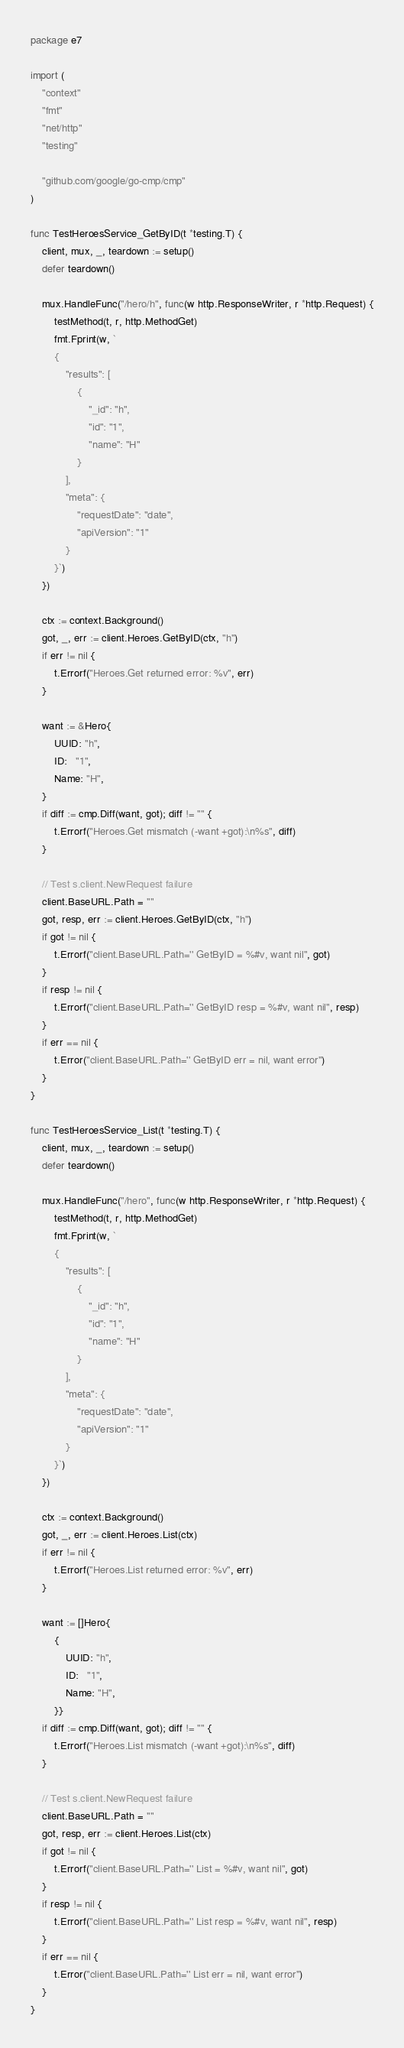Convert code to text. <code><loc_0><loc_0><loc_500><loc_500><_Go_>package e7

import (
	"context"
	"fmt"
	"net/http"
	"testing"

	"github.com/google/go-cmp/cmp"
)

func TestHeroesService_GetByID(t *testing.T) {
	client, mux, _, teardown := setup()
	defer teardown()

	mux.HandleFunc("/hero/h", func(w http.ResponseWriter, r *http.Request) {
		testMethod(t, r, http.MethodGet)
		fmt.Fprint(w, `
		{
			"results": [
				{
					"_id": "h",
					"id": "1",
					"name": "H"
				}
			],
			"meta": {
				"requestDate": "date",
				"apiVersion": "1"
			}
		}`)
	})

	ctx := context.Background()
	got, _, err := client.Heroes.GetByID(ctx, "h")
	if err != nil {
		t.Errorf("Heroes.Get returned error: %v", err)
	}

	want := &Hero{
		UUID: "h",
		ID:   "1",
		Name: "H",
	}
	if diff := cmp.Diff(want, got); diff != "" {
		t.Errorf("Heroes.Get mismatch (-want +got):\n%s", diff)
	}

	// Test s.client.NewRequest failure
	client.BaseURL.Path = ""
	got, resp, err := client.Heroes.GetByID(ctx, "h")
	if got != nil {
		t.Errorf("client.BaseURL.Path='' GetByID = %#v, want nil", got)
	}
	if resp != nil {
		t.Errorf("client.BaseURL.Path='' GetByID resp = %#v, want nil", resp)
	}
	if err == nil {
		t.Error("client.BaseURL.Path='' GetByID err = nil, want error")
	}
}

func TestHeroesService_List(t *testing.T) {
	client, mux, _, teardown := setup()
	defer teardown()

	mux.HandleFunc("/hero", func(w http.ResponseWriter, r *http.Request) {
		testMethod(t, r, http.MethodGet)
		fmt.Fprint(w, `
		{
			"results": [
				{
					"_id": "h",
					"id": "1",
					"name": "H"
				}
			],
			"meta": {
				"requestDate": "date",
				"apiVersion": "1"
			}
		}`)
	})

	ctx := context.Background()
	got, _, err := client.Heroes.List(ctx)
	if err != nil {
		t.Errorf("Heroes.List returned error: %v", err)
	}

	want := []Hero{
		{
			UUID: "h",
			ID:   "1",
			Name: "H",
		}}
	if diff := cmp.Diff(want, got); diff != "" {
		t.Errorf("Heroes.List mismatch (-want +got):\n%s", diff)
	}

	// Test s.client.NewRequest failure
	client.BaseURL.Path = ""
	got, resp, err := client.Heroes.List(ctx)
	if got != nil {
		t.Errorf("client.BaseURL.Path='' List = %#v, want nil", got)
	}
	if resp != nil {
		t.Errorf("client.BaseURL.Path='' List resp = %#v, want nil", resp)
	}
	if err == nil {
		t.Error("client.BaseURL.Path='' List err = nil, want error")
	}
}
</code> 